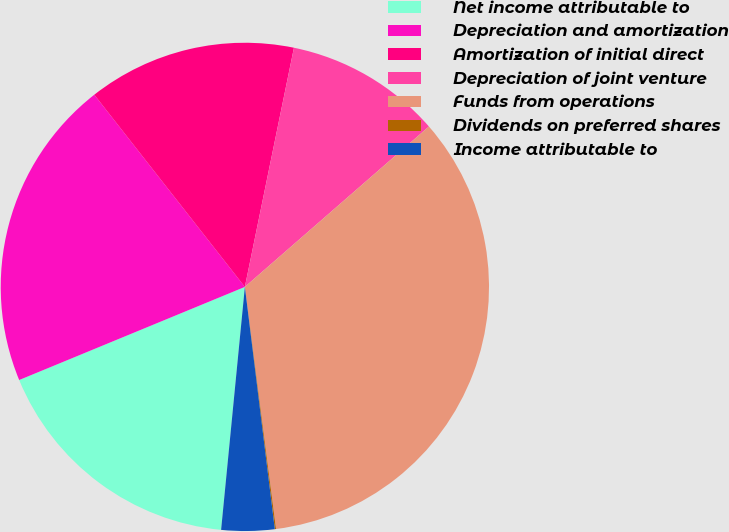Convert chart to OTSL. <chart><loc_0><loc_0><loc_500><loc_500><pie_chart><fcel>Net income attributable to<fcel>Depreciation and amortization<fcel>Amortization of initial direct<fcel>Depreciation of joint venture<fcel>Funds from operations<fcel>Dividends on preferred shares<fcel>Income attributable to<nl><fcel>17.22%<fcel>20.65%<fcel>13.8%<fcel>10.37%<fcel>34.37%<fcel>0.08%<fcel>3.51%<nl></chart> 